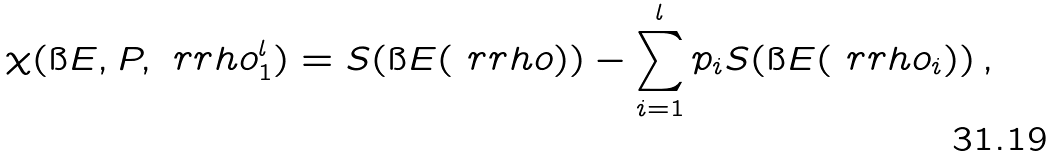Convert formula to latex. <formula><loc_0><loc_0><loc_500><loc_500>\chi ( \i E , P , \ r r h o _ { 1 } ^ { l } ) = S ( \i E ( \ r r h o ) ) - \sum _ { i = 1 } ^ { l } p _ { i } S ( \i E ( \ r r h o _ { i } ) ) \, ,</formula> 